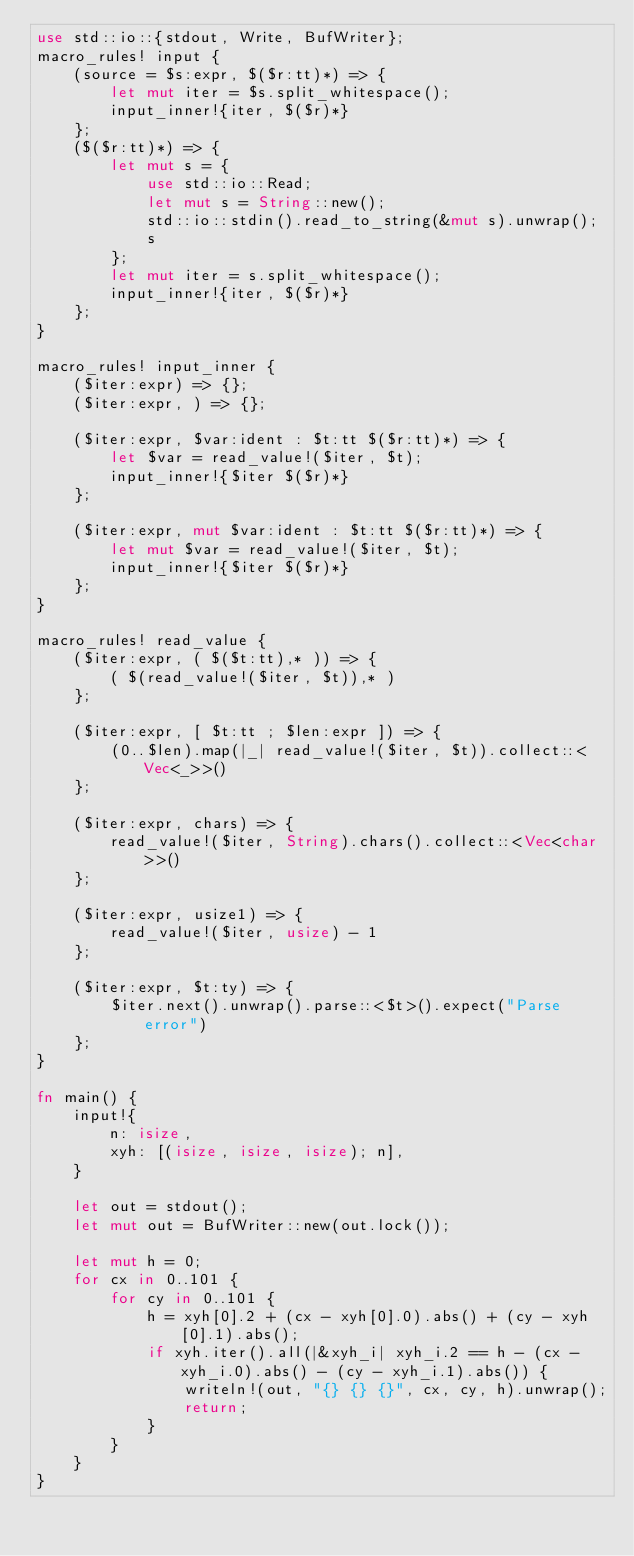<code> <loc_0><loc_0><loc_500><loc_500><_Rust_>use std::io::{stdout, Write, BufWriter};
macro_rules! input {
    (source = $s:expr, $($r:tt)*) => {
        let mut iter = $s.split_whitespace();
        input_inner!{iter, $($r)*}
    };
    ($($r:tt)*) => {
        let mut s = {
            use std::io::Read;
            let mut s = String::new();
            std::io::stdin().read_to_string(&mut s).unwrap();
            s
        };
        let mut iter = s.split_whitespace();
        input_inner!{iter, $($r)*}
    };
}

macro_rules! input_inner {
    ($iter:expr) => {};
    ($iter:expr, ) => {};

    ($iter:expr, $var:ident : $t:tt $($r:tt)*) => {
        let $var = read_value!($iter, $t);
        input_inner!{$iter $($r)*}
    };

    ($iter:expr, mut $var:ident : $t:tt $($r:tt)*) => {
        let mut $var = read_value!($iter, $t);
        input_inner!{$iter $($r)*}
    };
}

macro_rules! read_value {
    ($iter:expr, ( $($t:tt),* )) => {
        ( $(read_value!($iter, $t)),* )
    };

    ($iter:expr, [ $t:tt ; $len:expr ]) => {
        (0..$len).map(|_| read_value!($iter, $t)).collect::<Vec<_>>()
    };

    ($iter:expr, chars) => {
        read_value!($iter, String).chars().collect::<Vec<char>>()
    };

    ($iter:expr, usize1) => {
        read_value!($iter, usize) - 1
    };

    ($iter:expr, $t:ty) => {
        $iter.next().unwrap().parse::<$t>().expect("Parse error")
    };
}

fn main() {
    input!{
        n: isize,
        xyh: [(isize, isize, isize); n],
    }

    let out = stdout();
    let mut out = BufWriter::new(out.lock());

    let mut h = 0;
    for cx in 0..101 {
        for cy in 0..101 {
            h = xyh[0].2 + (cx - xyh[0].0).abs() + (cy - xyh[0].1).abs();
            if xyh.iter().all(|&xyh_i| xyh_i.2 == h - (cx - xyh_i.0).abs() - (cy - xyh_i.1).abs()) {
                writeln!(out, "{} {} {}", cx, cy, h).unwrap();
                return;
            }
        }
    }
}</code> 